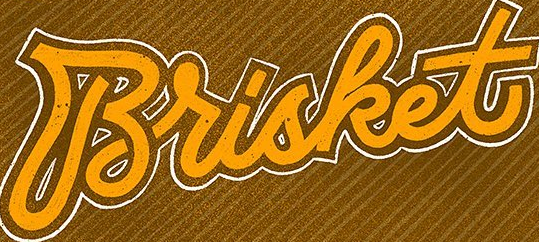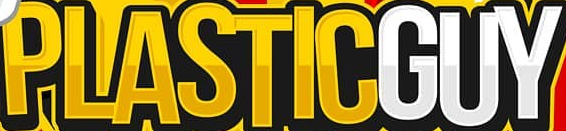What text appears in these images from left to right, separated by a semicolon? Brisket; PLASTICGUY 